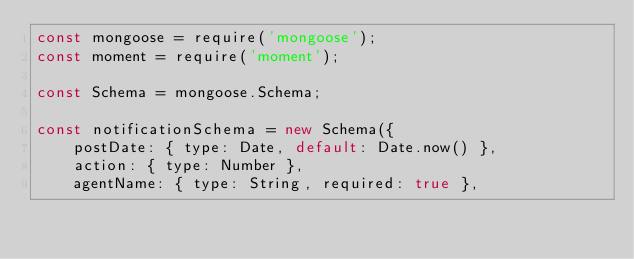<code> <loc_0><loc_0><loc_500><loc_500><_JavaScript_>const mongoose = require('mongoose');
const moment = require('moment');

const Schema = mongoose.Schema;

const notificationSchema = new Schema({
	postDate: { type: Date, default: Date.now() },
	action: { type: Number },
	agentName: { type: String, required: true },</code> 